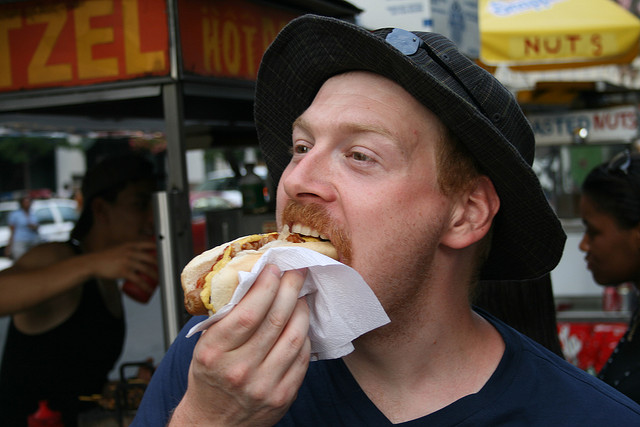Read all the text in this image. ZEL HOT NUT S MASTER NUTS 